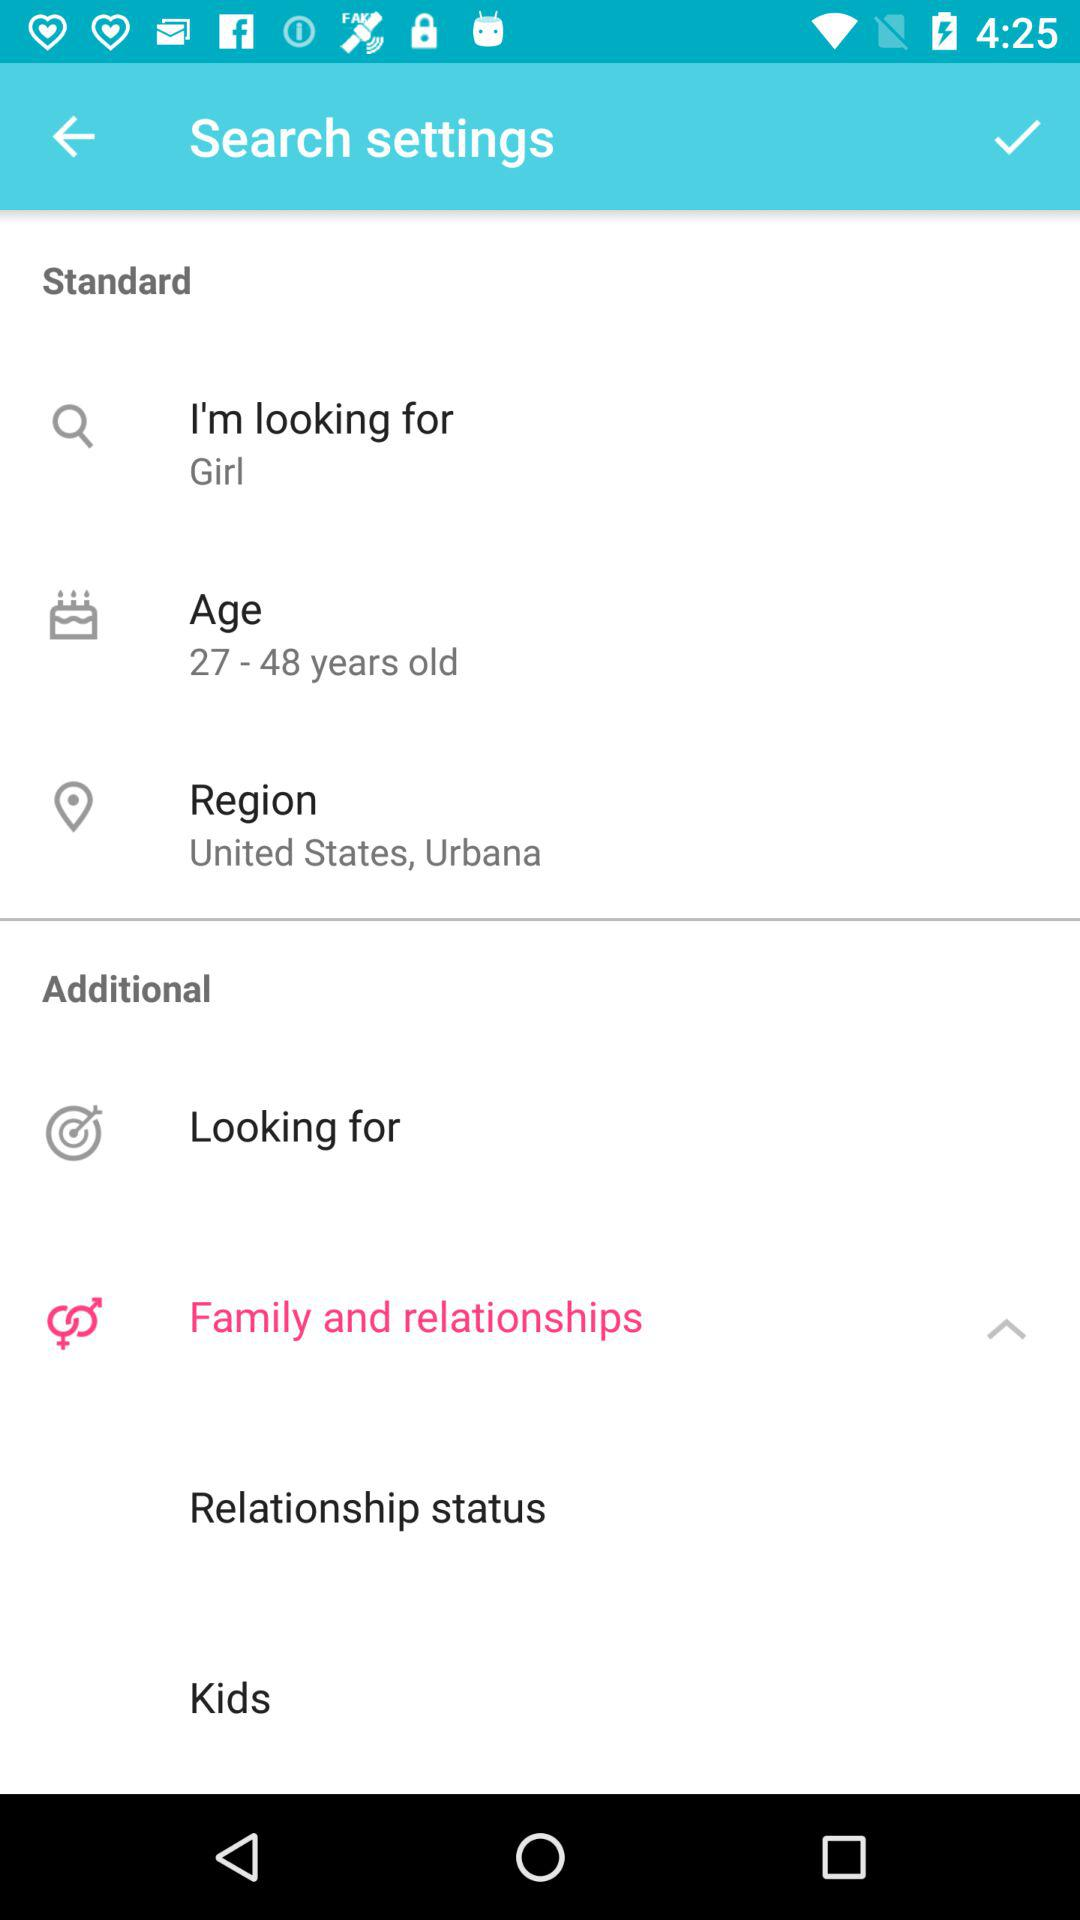What is the location? The location is United States, Urbana. 